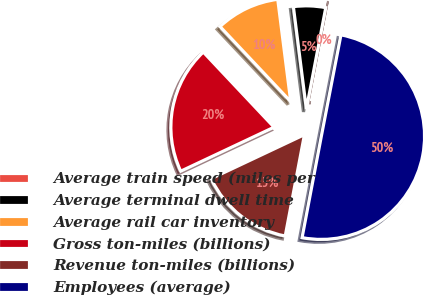Convert chart. <chart><loc_0><loc_0><loc_500><loc_500><pie_chart><fcel>Average train speed (miles per<fcel>Average terminal dwell time<fcel>Average rail car inventory<fcel>Gross ton-miles (billions)<fcel>Revenue ton-miles (billions)<fcel>Employees (average)<nl><fcel>0.03%<fcel>5.02%<fcel>10.01%<fcel>19.99%<fcel>15.0%<fcel>49.94%<nl></chart> 